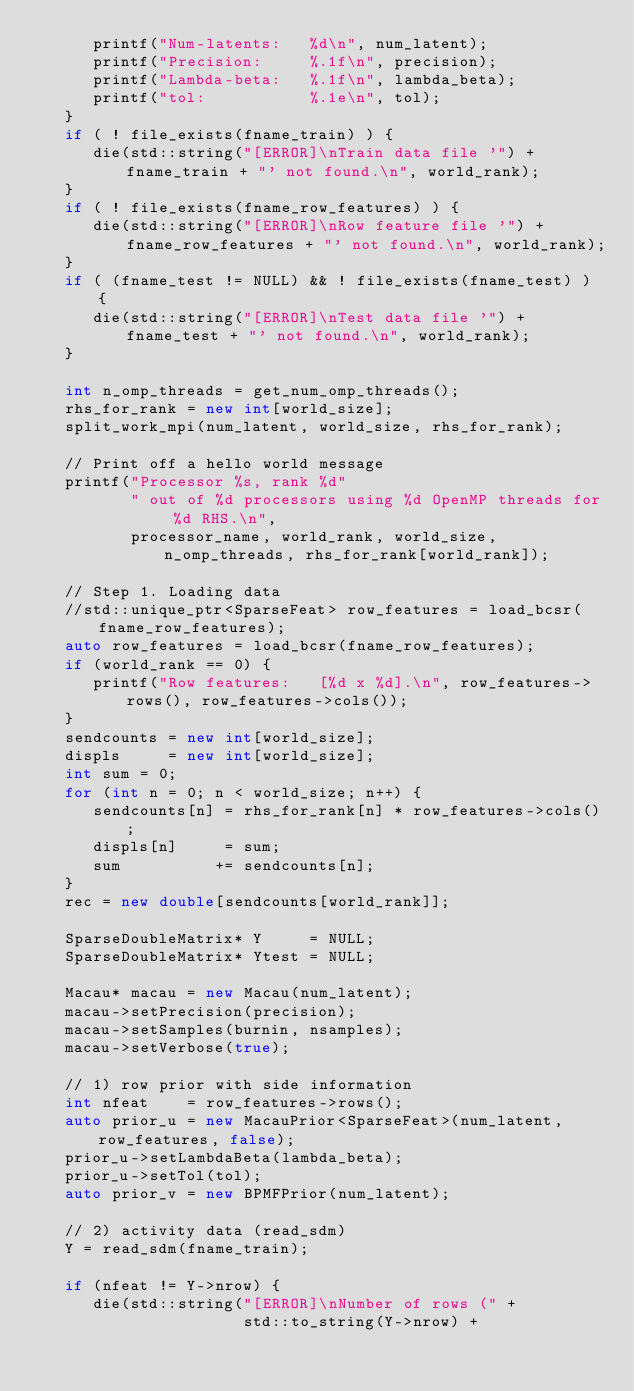Convert code to text. <code><loc_0><loc_0><loc_500><loc_500><_C++_>      printf("Num-latents:   %d\n", num_latent);
      printf("Precision:     %.1f\n", precision);
      printf("Lambda-beta:   %.1f\n", lambda_beta);
      printf("tol:           %.1e\n", tol);
   }
   if ( ! file_exists(fname_train) ) {
      die(std::string("[ERROR]\nTrain data file '") + fname_train + "' not found.\n", world_rank);
   }
   if ( ! file_exists(fname_row_features) ) {
      die(std::string("[ERROR]\nRow feature file '") + fname_row_features + "' not found.\n", world_rank);
   }
   if ( (fname_test != NULL) && ! file_exists(fname_test) ) {
      die(std::string("[ERROR]\nTest data file '") + fname_test + "' not found.\n", world_rank);
   }

   int n_omp_threads = get_num_omp_threads();
   rhs_for_rank = new int[world_size];
   split_work_mpi(num_latent, world_size, rhs_for_rank);

   // Print off a hello world message
   printf("Processor %s, rank %d"
          " out of %d processors using %d OpenMP threads for %d RHS.\n",
          processor_name, world_rank, world_size, n_omp_threads, rhs_for_rank[world_rank]);

   // Step 1. Loading data
   //std::unique_ptr<SparseFeat> row_features = load_bcsr(fname_row_features);
   auto row_features = load_bcsr(fname_row_features);
   if (world_rank == 0) {
      printf("Row features:   [%d x %d].\n", row_features->rows(), row_features->cols());
   }
   sendcounts = new int[world_size];
   displs     = new int[world_size];
   int sum = 0;
   for (int n = 0; n < world_size; n++) {
      sendcounts[n] = rhs_for_rank[n] * row_features->cols();
      displs[n]     = sum;
      sum          += sendcounts[n];
   }
   rec = new double[sendcounts[world_rank]];

   SparseDoubleMatrix* Y     = NULL;
   SparseDoubleMatrix* Ytest = NULL;

   Macau* macau = new Macau(num_latent);
   macau->setPrecision(precision);
   macau->setSamples(burnin, nsamples);
   macau->setVerbose(true);

   // 1) row prior with side information
   int nfeat    = row_features->rows();
   auto prior_u = new MacauPrior<SparseFeat>(num_latent, row_features, false);
   prior_u->setLambdaBeta(lambda_beta);
   prior_u->setTol(tol);
   auto prior_v = new BPMFPrior(num_latent);

   // 2) activity data (read_sdm)
   Y = read_sdm(fname_train);

   if (nfeat != Y->nrow) {
      die(std::string("[ERROR]\nNumber of rows (" +
                      std::to_string(Y->nrow) +</code> 